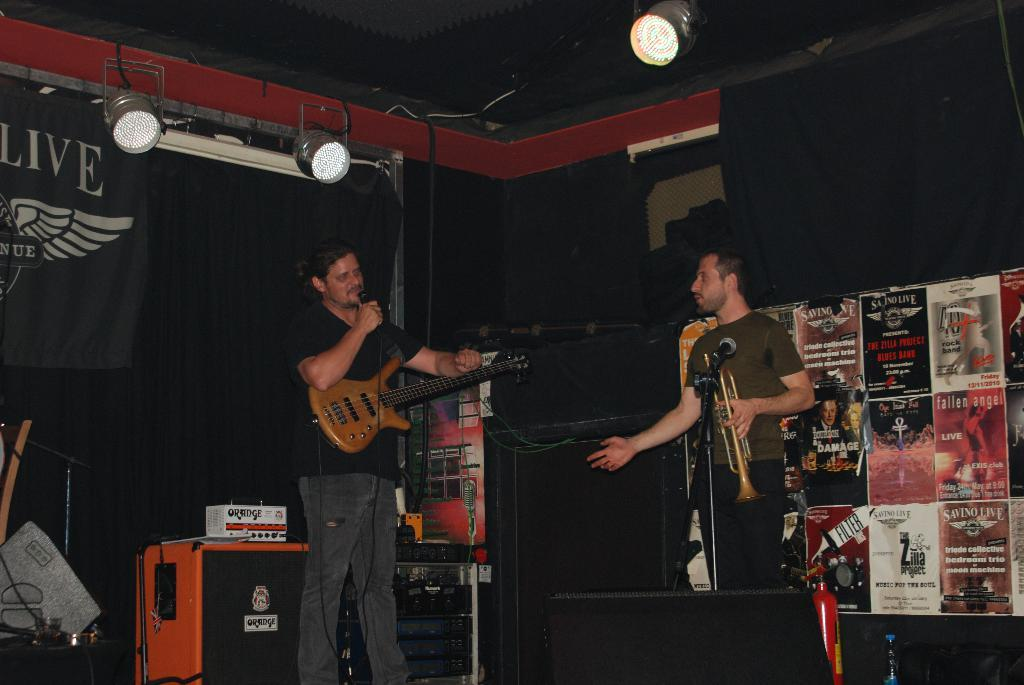What can be seen in the image that provides illumination? There are lights in the image. What decorative element is present in the image? There is a banner in the image. How many people are in the image? There are two people in the image. What is one of the people holding? One of the people is holding a guitar. What object is in front of the person holding the guitar? There is a microphone in front of the person holding the guitar. Can you tell me how many actors are performing on stage in the image? There is no stage or actors present in the image. What type of spade is being used by the person holding the guitar in the image? There is no spade present in the image; the person is holding a guitar and standing near a microphone. 